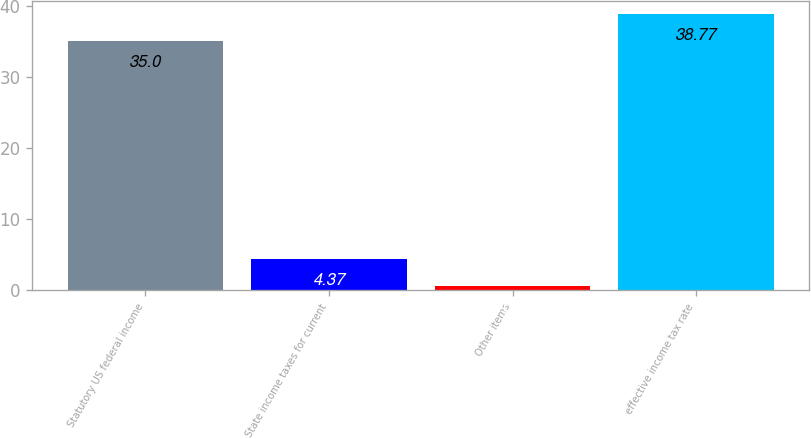<chart> <loc_0><loc_0><loc_500><loc_500><bar_chart><fcel>Statutory US federal income<fcel>State income taxes for current<fcel>Other items<fcel>effective income tax rate<nl><fcel>35<fcel>4.37<fcel>0.6<fcel>38.77<nl></chart> 